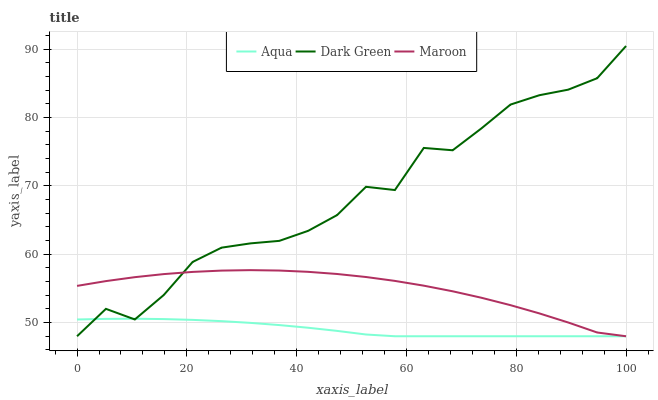Does Aqua have the minimum area under the curve?
Answer yes or no. Yes. Does Dark Green have the maximum area under the curve?
Answer yes or no. Yes. Does Maroon have the minimum area under the curve?
Answer yes or no. No. Does Maroon have the maximum area under the curve?
Answer yes or no. No. Is Aqua the smoothest?
Answer yes or no. Yes. Is Dark Green the roughest?
Answer yes or no. Yes. Is Maroon the smoothest?
Answer yes or no. No. Is Maroon the roughest?
Answer yes or no. No. Does Aqua have the lowest value?
Answer yes or no. Yes. Does Dark Green have the highest value?
Answer yes or no. Yes. Does Maroon have the highest value?
Answer yes or no. No. Does Dark Green intersect Aqua?
Answer yes or no. Yes. Is Dark Green less than Aqua?
Answer yes or no. No. Is Dark Green greater than Aqua?
Answer yes or no. No. 